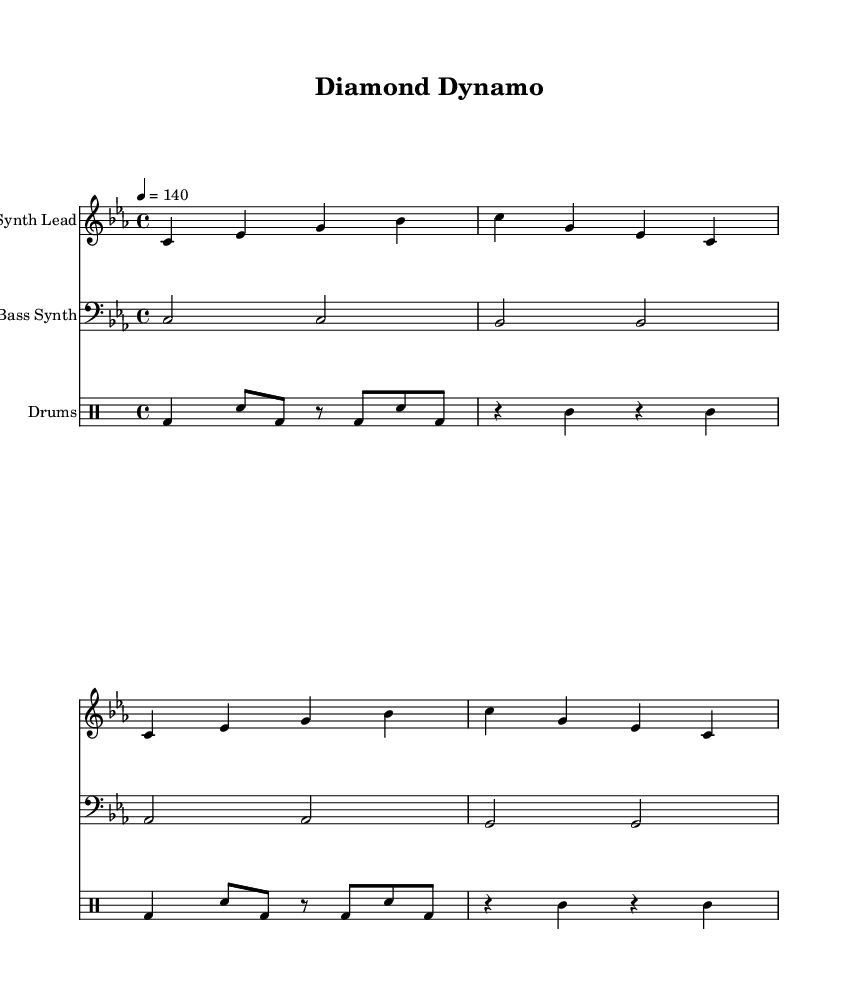What is the key signature of this music? The key signature is C minor, indicated by three flats in the key signature on the left side of the staff.
Answer: C minor What is the time signature of this music? The time signature is 4/4, which means there are four beats in each measure, as shown at the beginning of the score.
Answer: 4/4 What is the tempo marking for this piece? The tempo marking is quarter note equals 140, which is found above the staff and indicates the speed of the music.
Answer: 140 How many measures are in the synth lead part? The synth lead part contains four measures, as counted by the number of grouped vertical lines (bar lines) in the staff.
Answer: 4 What type of instrument is the bass part written for? The bass part is written for a bass synth, which is specified above the staff representing that part.
Answer: Bass Synth How many beats does the bass synth hold for in the first measure? The bass synth holds two beats in the first measure, as indicated by the half notes in the first measure of the bass staff.
Answer: 2 What rhythmic pattern is used for the drums in the first measure? The first measure features a bass drum and snare pattern, which is common in electronic music for creating a driving rhythm.
Answer: Bass drum and snare pattern 